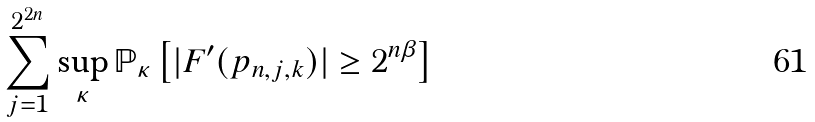<formula> <loc_0><loc_0><loc_500><loc_500>\sum _ { j = 1 } ^ { 2 ^ { 2 n } } \sup _ { \kappa } \mathbb { P } _ { \kappa } \left [ | F ^ { \prime } ( p _ { n , j , k } ) | \geq 2 ^ { n \beta } \right ]</formula> 